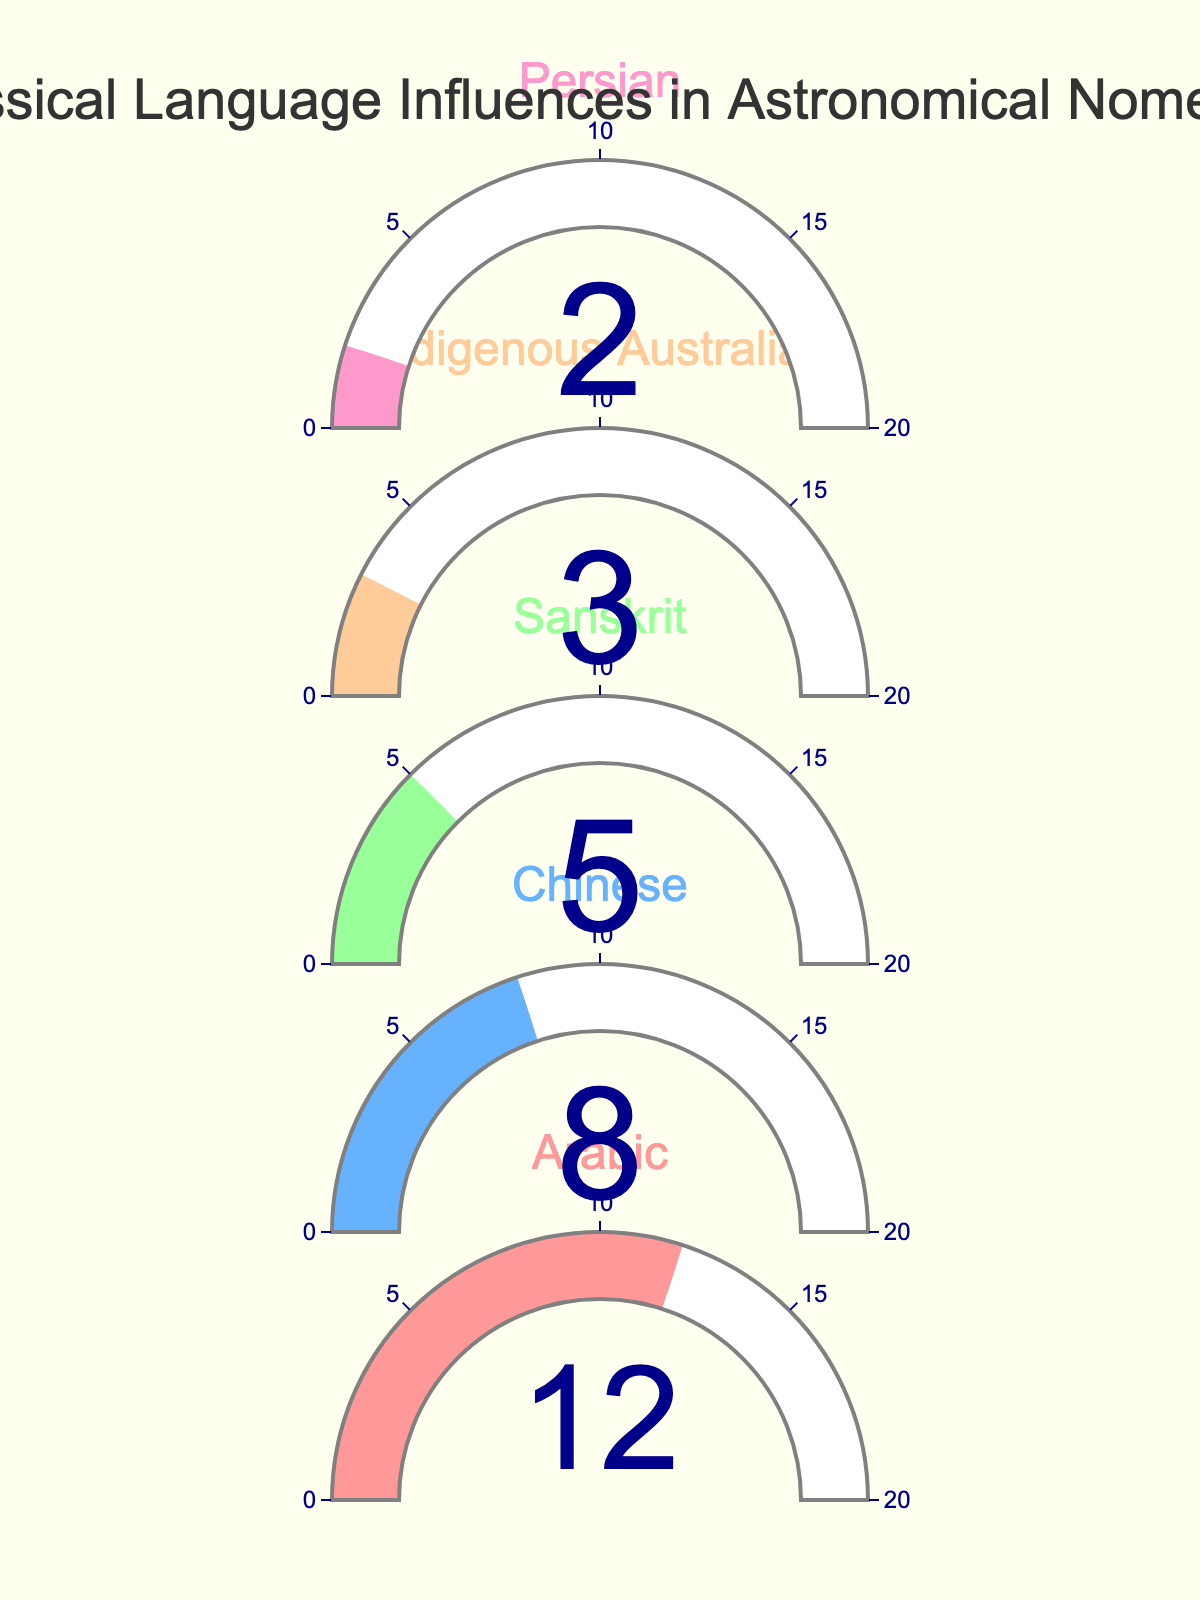What is the title of the chart? The title is usually placed prominently at the top of the chart, and it describes the overall subject of the visual. In this case, the title states the main topic being analyzed.
Answer: Non-classical Language Influences in Astronomical Nomenclature What percentage does Arabic contribute? Each gauge in the chart displays a percentage value and is labeled with its respective category. The gauge labeled "Arabic" shows the percentage in its center.
Answer: 12% Which language has the lowest influence percentage? By examining all the gauges, we look for the one with the smallest value displayed. The gauge labeled "Persian" shows the lowest percentage.
Answer: Persian How much higher is the influence of Arabic compared to Chinese? Find the percentage values for both languages and subtract the Chinese percentage from the Arabic percentage. Arabic has 12%, and Chinese has 8%. So, the difference is 12% - 8%.
Answer: 4% What is the combined influence percentage of Indigenous Australian and Persian languages? Add the percentages of Indigenous Australian (3%) and Persian (2%) influences.
Answer: 5% Which category has a percentage less than 10%? Examine each gauge and identify those with values below 10%. Both Chinese (8%) and Sanskrit (5%) meet this criteria.
Answer: Chinese, Sanskrit What's the difference in percentage between the highest and lowest influences? Identify the highest (Arabic, 12%) and the lowest (Persian, 2%) percentages, then subtract the lowest from the highest (12% - 2%).
Answer: 10% How many language categories are depicted in the chart? Count the number of gauges, as each gauge represents a different language category. There are five distinct categories labeled.
Answer: 5 